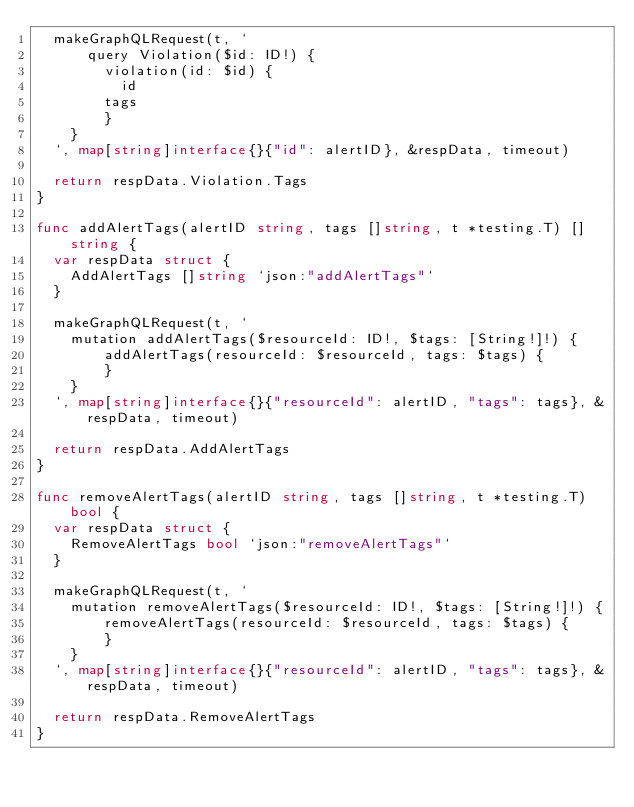Convert code to text. <code><loc_0><loc_0><loc_500><loc_500><_Go_>	makeGraphQLRequest(t, `
  		query Violation($id: ID!) {
  			violation(id: $id) {
    			id
				tags
  			}
		}
	`, map[string]interface{}{"id": alertID}, &respData, timeout)

	return respData.Violation.Tags
}

func addAlertTags(alertID string, tags []string, t *testing.T) []string {
	var respData struct {
		AddAlertTags []string `json:"addAlertTags"`
	}

	makeGraphQLRequest(t, `
 		mutation addAlertTags($resourceId: ID!, $tags: [String!]!) {
  			addAlertTags(resourceId: $resourceId, tags: $tags) {
  			}
		}
	`, map[string]interface{}{"resourceId": alertID, "tags": tags}, &respData, timeout)

	return respData.AddAlertTags
}

func removeAlertTags(alertID string, tags []string, t *testing.T) bool {
	var respData struct {
		RemoveAlertTags bool `json:"removeAlertTags"`
	}

	makeGraphQLRequest(t, `
 		mutation removeAlertTags($resourceId: ID!, $tags: [String!]!) {
  			removeAlertTags(resourceId: $resourceId, tags: $tags) {
  			}
		}
	`, map[string]interface{}{"resourceId": alertID, "tags": tags}, &respData, timeout)

	return respData.RemoveAlertTags
}
</code> 